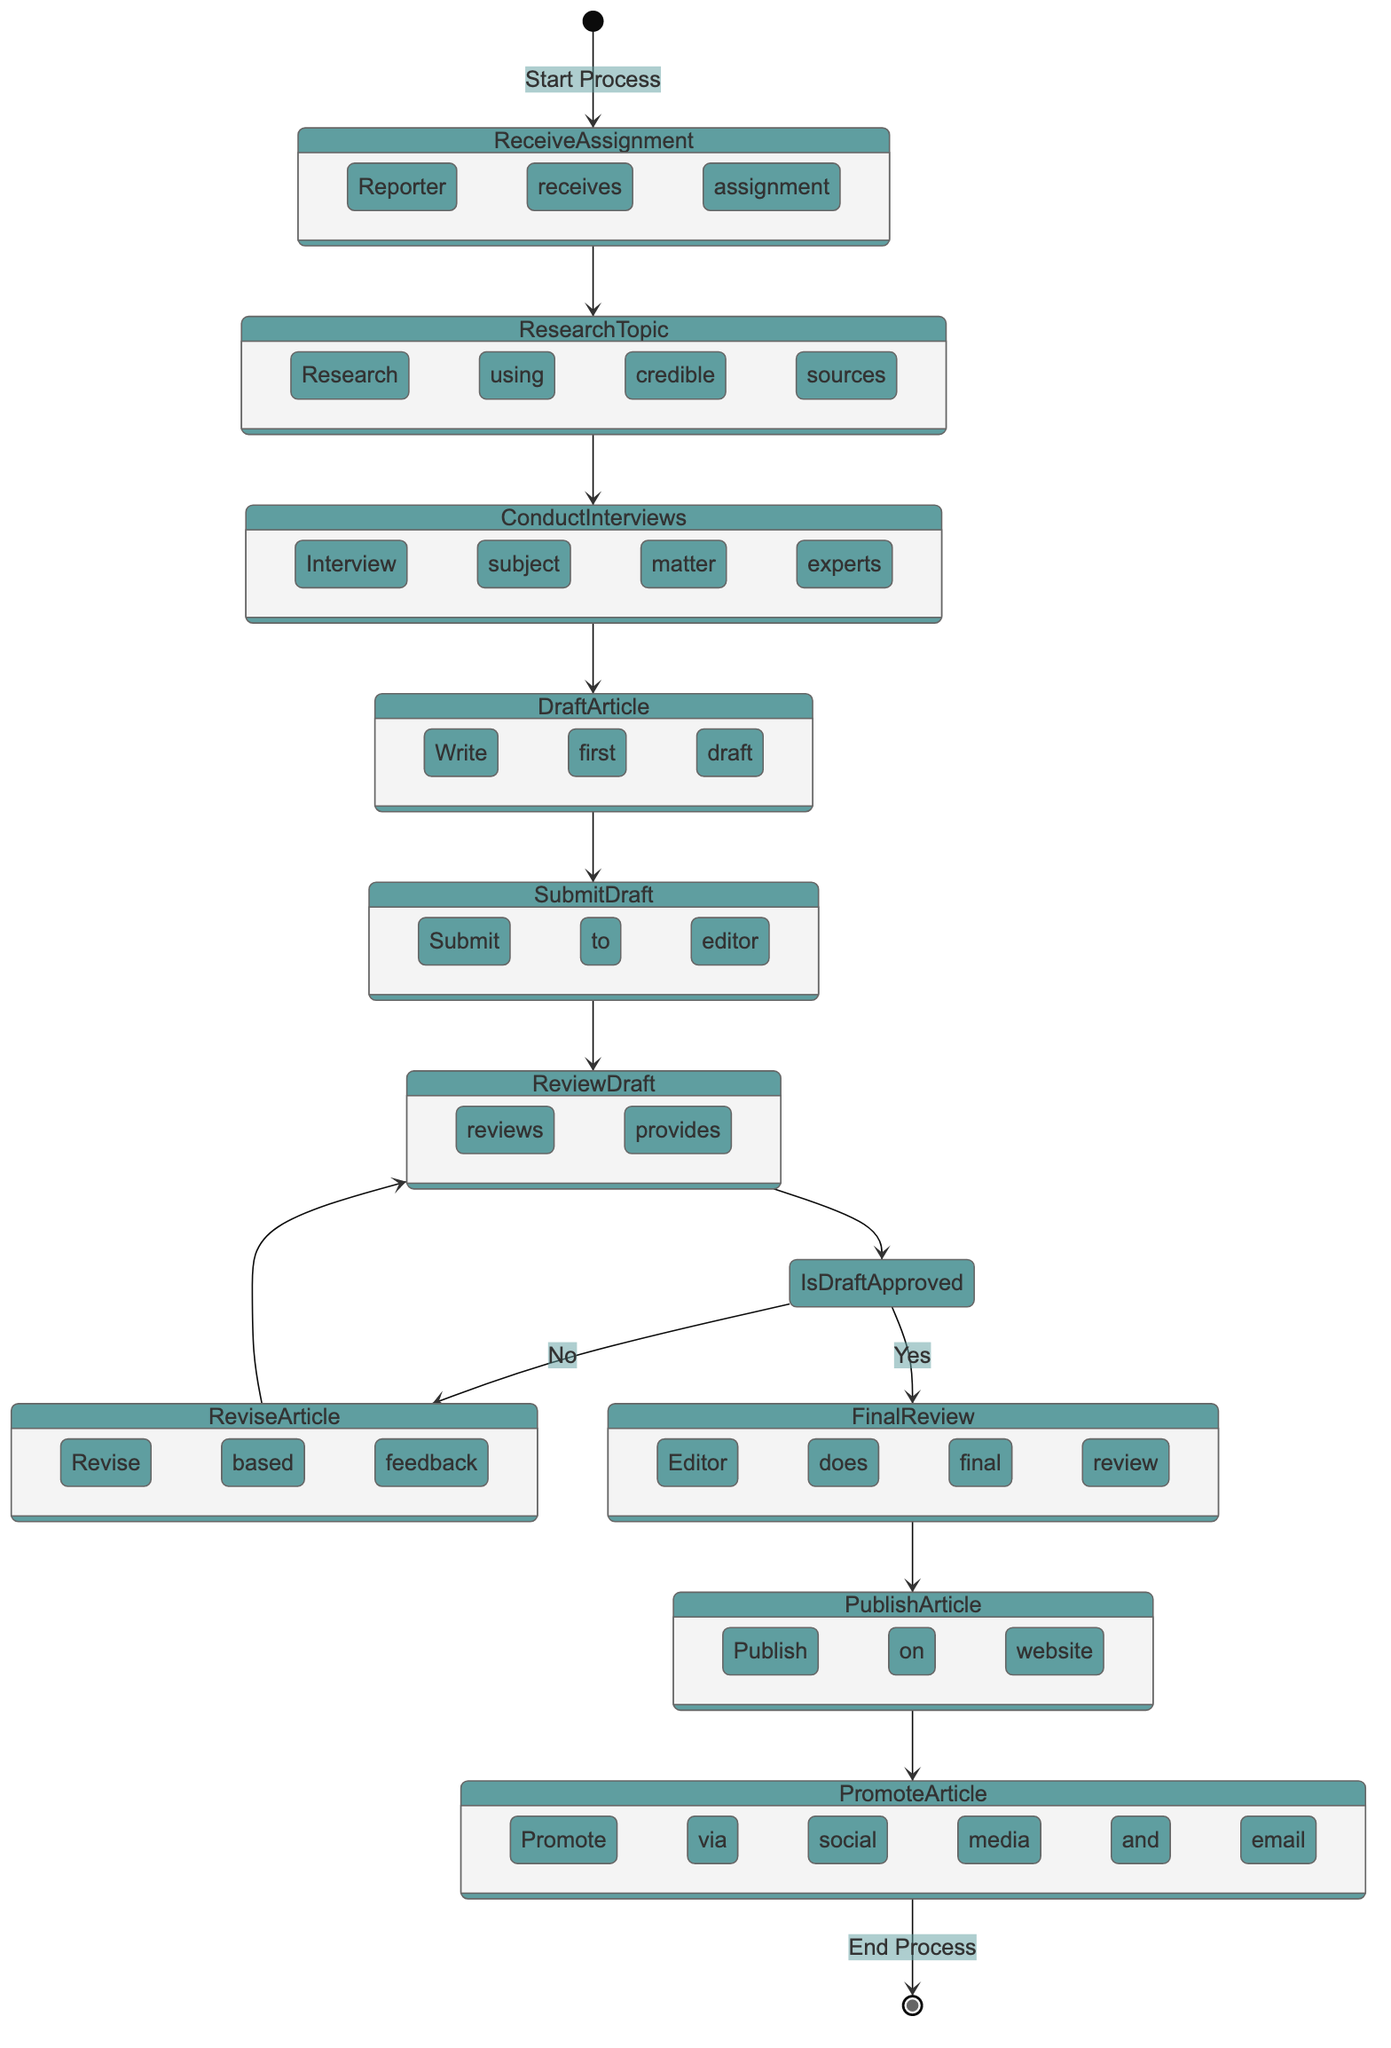What is the first activity in the process? The first activity is indicated by the arrow leading from the start node to "Receive Assignment," which signifies that the process begins when the reporter receives the assignment from the editor.
Answer: Receive Assignment What happens after the "Research Topic" activity? After "Research Topic," the flow proceeds to "Conduct Interviews," as illustrated in the diagram where an arrow connects these two activities sequentially.
Answer: Conduct Interviews How many main activities are in the process? The main activities are those listed prior to the decisions and include ten distinct nodes, as counted from the start to the end of the diagram flow.
Answer: 10 What decision is made after the "Review Draft"? The decision made is whether the draft is approved or needs more revisions, as represented by the "Is Draft Approved?" node that branches from the "Review Draft" activity.
Answer: Is Draft Approved? What happens if the draft is not approved? If the draft is not approved, the process proceeds to the "Revise Article" activity, allowing the reporter to make necessary changes based on feedback before re-entering the review process.
Answer: Revise Article What is the final activity in the publication process? The final activity, indicated by the last connection in the diagram, is "Promote Article," which concludes the process as it leads back to the end node.
Answer: Promote Article Which activity directly follows the "Final Review"? The activity that follows the "Final Review" is "Publish Article," as shown by the flow that continues from one to the other in the sequence of operations.
Answer: Publish Article What key role does the editor play in this process? The editor is responsible for reviewing the draft and providing feedback, as indicated in multiple points in the diagram where "Review Draft" and "Final Review" both involve the editor's actions.
Answer: Reviewing draft What occurs just before the article is published? Before publication, a "Final Review" takes place, ensuring the article is thoroughly checked and approved by the editor, making it a critical step before "Publish Article."
Answer: Final Review 